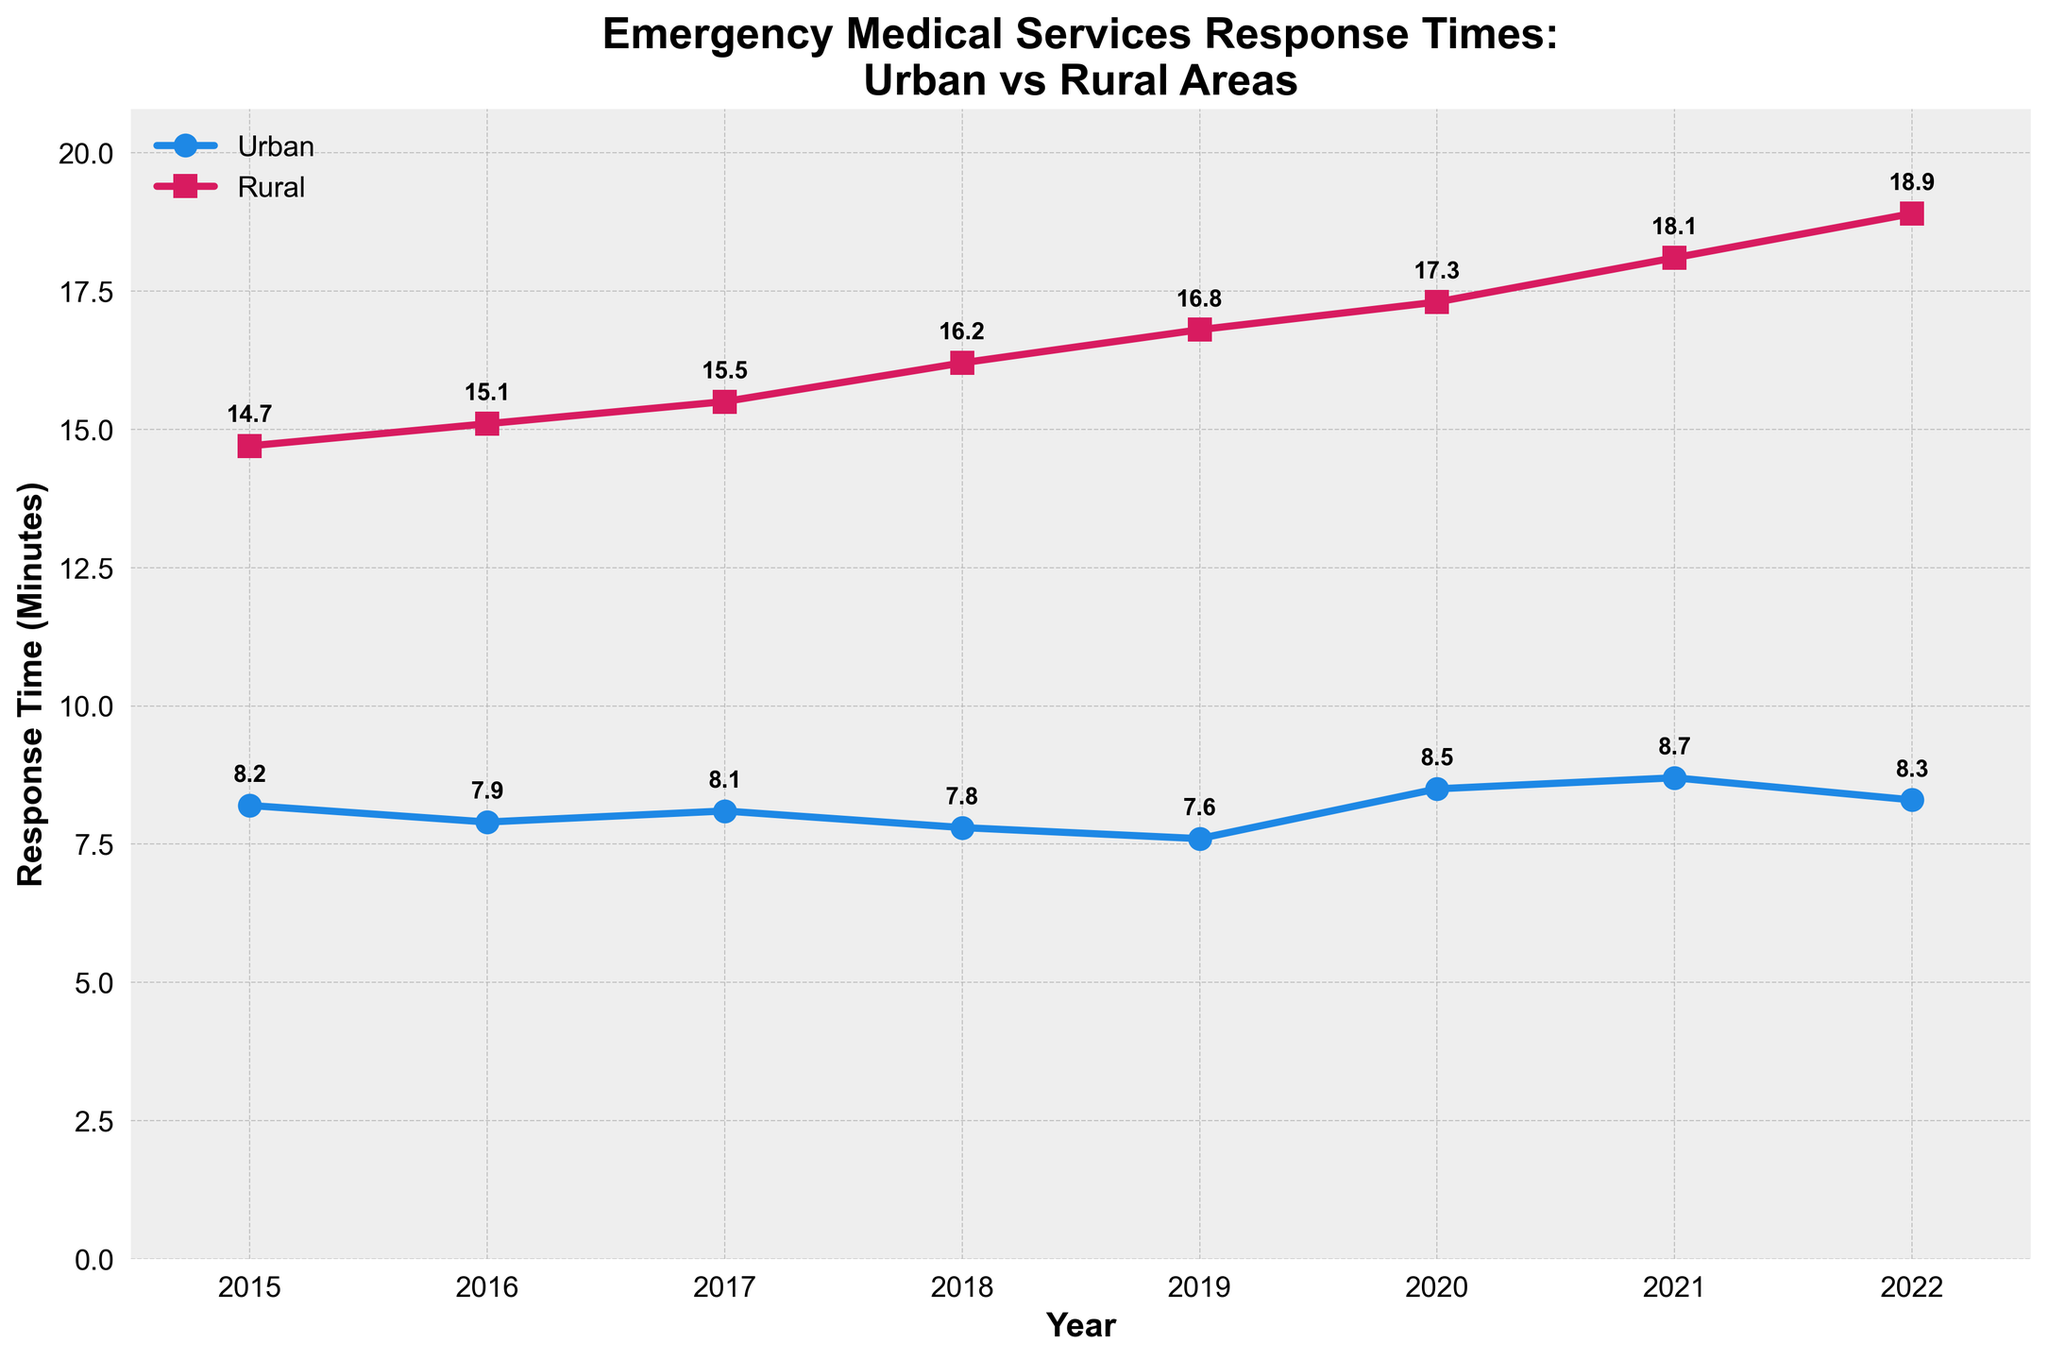What is the trend of urban response times from 2015 to 2022? The urban response times generally fluctuate slightly but tend to be around 8 minutes, with a slight peak in 2020 and 2021 but overall show a slight decrease over the years.
Answer: Slightly decreasing trend What is the trend of rural response times from 2015 to 2022? The rural response times consistently increase from 14.7 minutes in 2015 to 18.9 minutes in 2022.
Answer: Increasing trend How much did the urban response time change from 2015 to 2022? The urban response time in 2015 was 8.2 minutes and in 2022 was 8.3 minutes, showing a slight increase of 0.1 minutes.
Answer: Increased by 0.1 minutes At what year did rural response times surpass 16 minutes? In the year 2018, rural response times increased to 16.2 minutes, surpassing 16 minutes for the first time.
Answer: 2018 Which year had the maximum difference between urban and rural response times? In 2022, the urban response time was 8.3 minutes and the rural response time was 18.9 minutes, giving a difference of 10.6 minutes. This is the maximum value within the timeframe of the plot.
Answer: 2022 What is the average response time in urban areas over the given period? Sum the urban times: 8.2 + 7.9 + 8.1 + 7.8 + 7.6 + 8.5 + 8.7 + 8.3 = 65.1, then average this by dividing by the number of years (8): 65.1 / 8 = 8.14 minutes.
Answer: 8.14 minutes Which year had the shortest urban response time? In 2019, the urban response time was 7.6 minutes, which is the shortest time in the given period.
Answer: 2019 By how many minutes did rural response times increase from 2015 to 2022? The rural response time in 2015 was 14.7 minutes and in 2022 was 18.9 minutes, so the increase is 18.9 - 14.7 = 4.2 minutes.
Answer: Increased by 4.2 minutes 